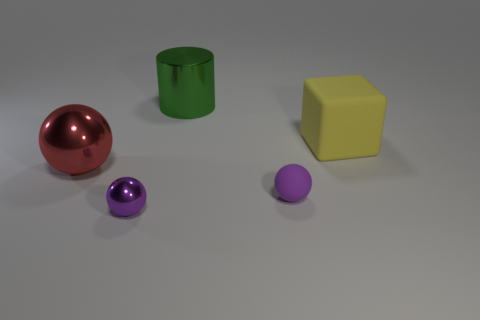Subtract all tiny rubber balls. How many balls are left? 2 Add 2 purple spheres. How many objects exist? 7 Subtract all blue cylinders. How many purple spheres are left? 2 Subtract all red balls. How many balls are left? 2 Subtract all cylinders. How many objects are left? 4 Subtract all yellow spheres. Subtract all purple blocks. How many spheres are left? 3 Subtract all big red metal balls. Subtract all small purple metal balls. How many objects are left? 3 Add 3 rubber objects. How many rubber objects are left? 5 Add 4 large red things. How many large red things exist? 5 Subtract 0 green cubes. How many objects are left? 5 